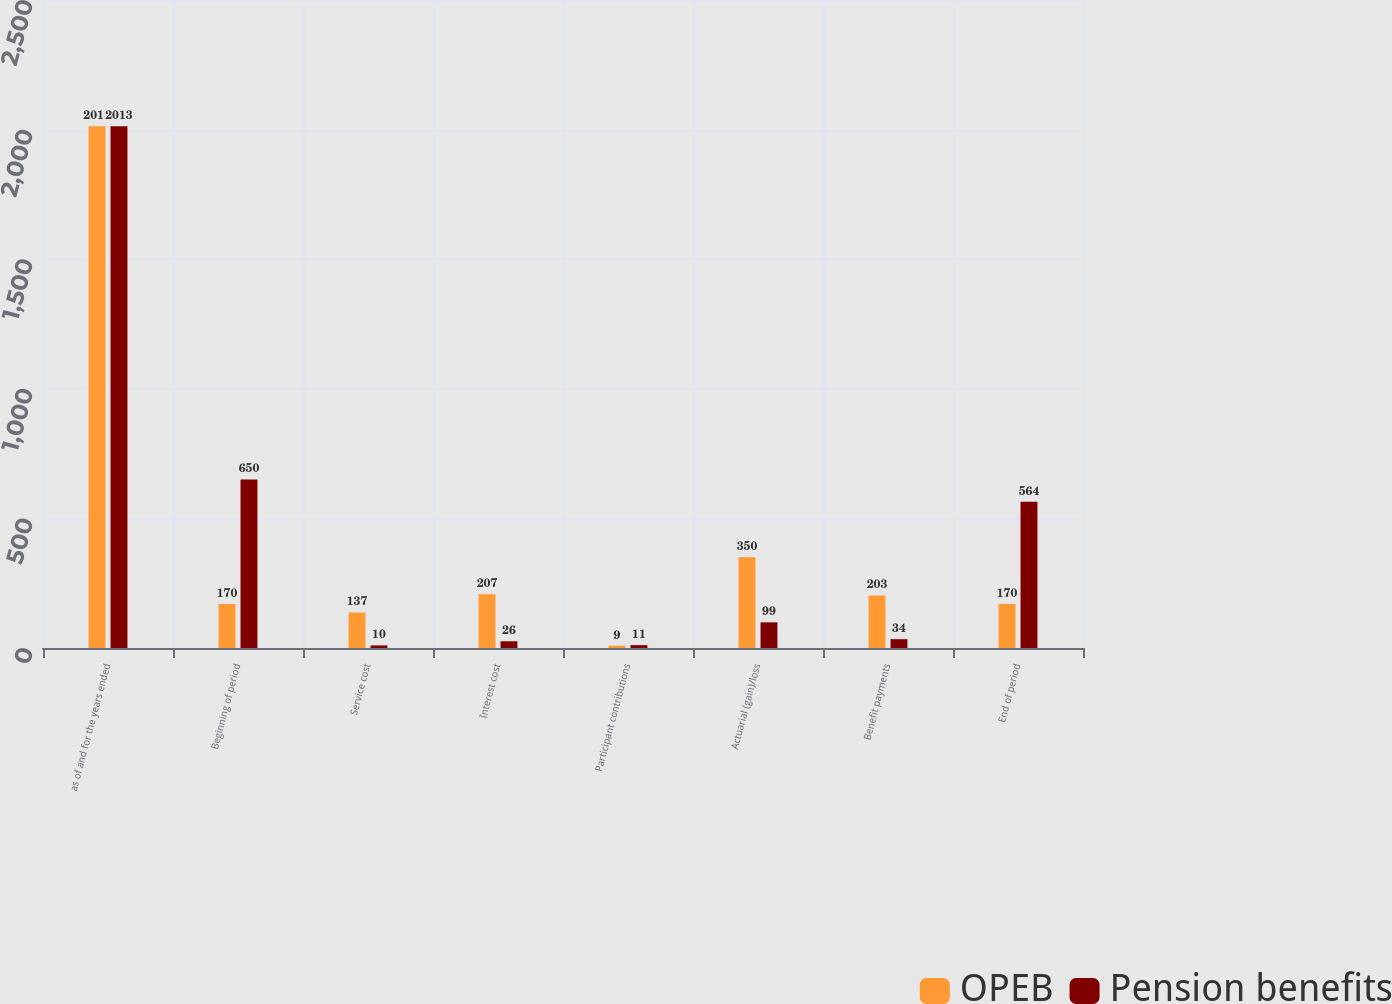<chart> <loc_0><loc_0><loc_500><loc_500><stacked_bar_chart><ecel><fcel>as of and for the years ended<fcel>Beginning of period<fcel>Service cost<fcel>Interest cost<fcel>Participant contributions<fcel>Actuarial (gain)/loss<fcel>Benefit payments<fcel>End of period<nl><fcel>OPEB<fcel>2013<fcel>170<fcel>137<fcel>207<fcel>9<fcel>350<fcel>203<fcel>170<nl><fcel>Pension benefits<fcel>2013<fcel>650<fcel>10<fcel>26<fcel>11<fcel>99<fcel>34<fcel>564<nl></chart> 